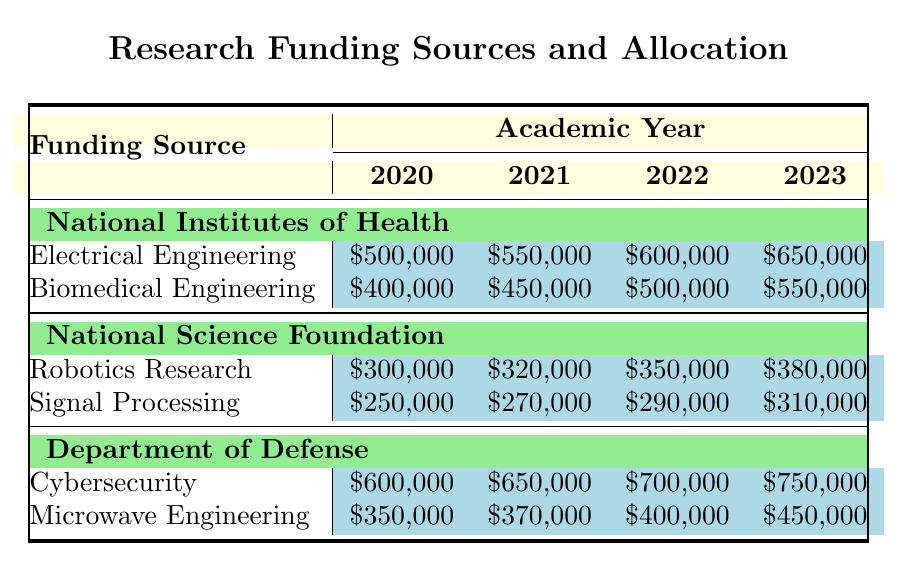What was the amount of funding allocated to Electrical Engineering in 2021? In the table, under the National Institutes of Health for the year 2021, the funding allocated to Electrical Engineering is listed as $550,000.
Answer: $550,000 Which funding source provided the highest amount for Cybersecurity in 2022? In the table, the Department of Defense provided the highest funding amount for Cybersecurity in 2022, which is $700,000. Other sources are not listed for Cybersecurity, confirming that it is the highest.
Answer: Department of Defense What is the total funding for Robotics Research from 2020 to 2023? To find the total funding for Robotics Research, add the amounts from each year: $300,000 (2020) + $320,000 (2021) + $350,000 (2022) + $380,000 (2023) = $1,350,000.
Answer: $1,350,000 Is the funding for Biomedical Engineering always increasing? By examining the table, the funding amounts for Biomedical Engineering are: $400,000 (2020), $450,000 (2021), $500,000 (2022), and $550,000 (2023), which shows a consistent increase each year. Therefore, it is true that funding is always increasing.
Answer: Yes What is the average funding amount for Signal Processing over the four years? To calculate the average funding for Signal Processing, sum the funding amounts: $250,000 (2020) + $270,000 (2021) + $290,000 (2022) + $310,000 (2023) = $1,120,000. Then, divide by the number of years (4): $1,120,000 / 4 = $280,000.
Answer: $280,000 Which discipline received the least amount of funding in 2020? By examining the table, the smallest funding amount in 2020 is for Signal Processing, which received $250,000. This is less than any other discipline listed.
Answer: Signal Processing What was the percentage increase in funding for Microwave Engineering from 2020 to 2023? The funding for Microwave Engineering in 2020 was $350,000 and in 2023 it was $450,000. The percentage increase can be calculated using the formula: [(450,000 - 350,000) / 350,000] * 100 = 28.57%. Therefore, the increase is approximately 28.57%.
Answer: 28.57% How did the funding for Electrical Engineering compare to that for Biomedical Engineering in 2023? In 2023, funding for Electrical Engineering was $650,000 whereas funding for Biomedical Engineering was $550,000. Electrical Engineering received $100,000 more than Biomedical Engineering.
Answer: $100,000 more What is the total funding allocated by the National Science Foundation across all disciplines in 2021? To find the total funding from the National Science Foundation in 2021, sum the amounts allocated to each discipline: $320,000 (Robotics Research) + $270,000 (Signal Processing) = $590,000.
Answer: $590,000 Which year had the highest funding for Cybersecurity, and what was the amount? By reviewing the table, Cybersecurity funding increased each year, reaching the highest amount of $750,000 in 2023. There is no other funding source for Cybersecurity that competes with this amount.
Answer: 2023, $750,000 